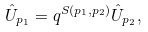<formula> <loc_0><loc_0><loc_500><loc_500>\hat { U } _ { p _ { 1 } } = q ^ { S ( p _ { 1 } , p _ { 2 } ) } \hat { U } _ { p _ { 2 } } ,</formula> 